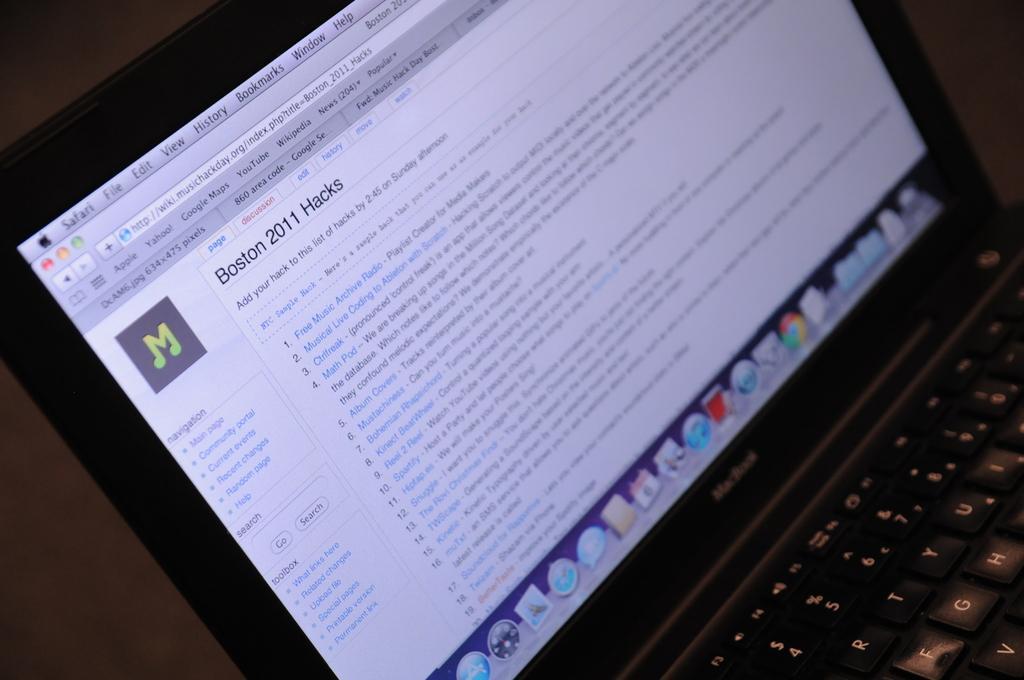How would you summarize this image in a sentence or two? In this picture we can see a laptop and keys. On the laptop screen there are icons, files, words and other things. 